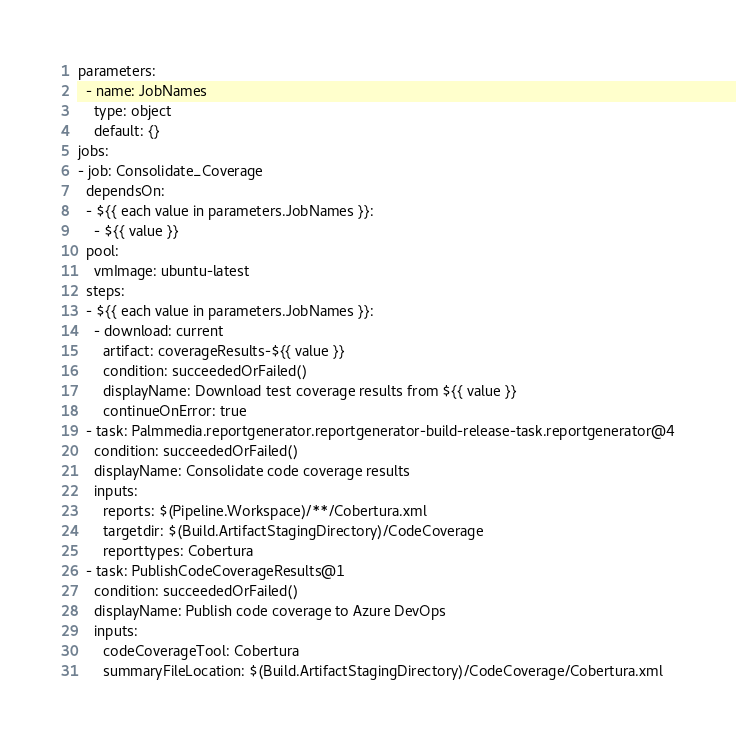Convert code to text. <code><loc_0><loc_0><loc_500><loc_500><_YAML_>parameters:
  - name: JobNames
    type: object
    default: {}
jobs:
- job: Consolidate_Coverage
  dependsOn:
  - ${{ each value in parameters.JobNames }}:
    - ${{ value }}
  pool:
    vmImage: ubuntu-latest
  steps:
  - ${{ each value in parameters.JobNames }}:
    - download: current
      artifact: coverageResults-${{ value }}
      condition: succeededOrFailed()
      displayName: Download test coverage results from ${{ value }}
      continueOnError: true
  - task: Palmmedia.reportgenerator.reportgenerator-build-release-task.reportgenerator@4
    condition: succeededOrFailed()
    displayName: Consolidate code coverage results
    inputs:
      reports: $(Pipeline.Workspace)/**/Cobertura.xml
      targetdir: $(Build.ArtifactStagingDirectory)/CodeCoverage
      reporttypes: Cobertura
  - task: PublishCodeCoverageResults@1
    condition: succeededOrFailed()
    displayName: Publish code coverage to Azure DevOps
    inputs:
      codeCoverageTool: Cobertura
      summaryFileLocation: $(Build.ArtifactStagingDirectory)/CodeCoverage/Cobertura.xml</code> 